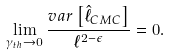<formula> <loc_0><loc_0><loc_500><loc_500>\lim _ { \gamma _ { t h } \rightarrow 0 } \frac { v a r \left [ \hat { \ell } _ { C M C } \right ] } { \ell ^ { 2 - \epsilon } } = 0 .</formula> 